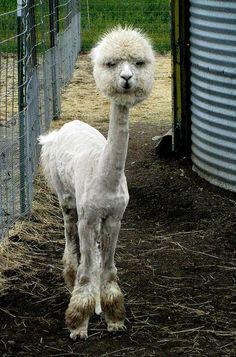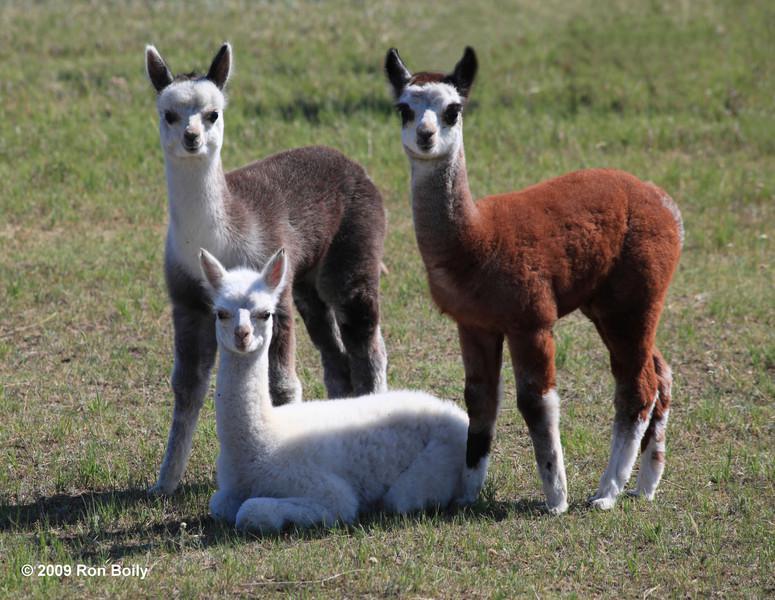The first image is the image on the left, the second image is the image on the right. Given the left and right images, does the statement "The left image contains one standing brown-and-white llama, and the right image contains at least two all white llamas." hold true? Answer yes or no. No. The first image is the image on the left, the second image is the image on the right. Examine the images to the left and right. Is the description "There are four llamas." accurate? Answer yes or no. Yes. 